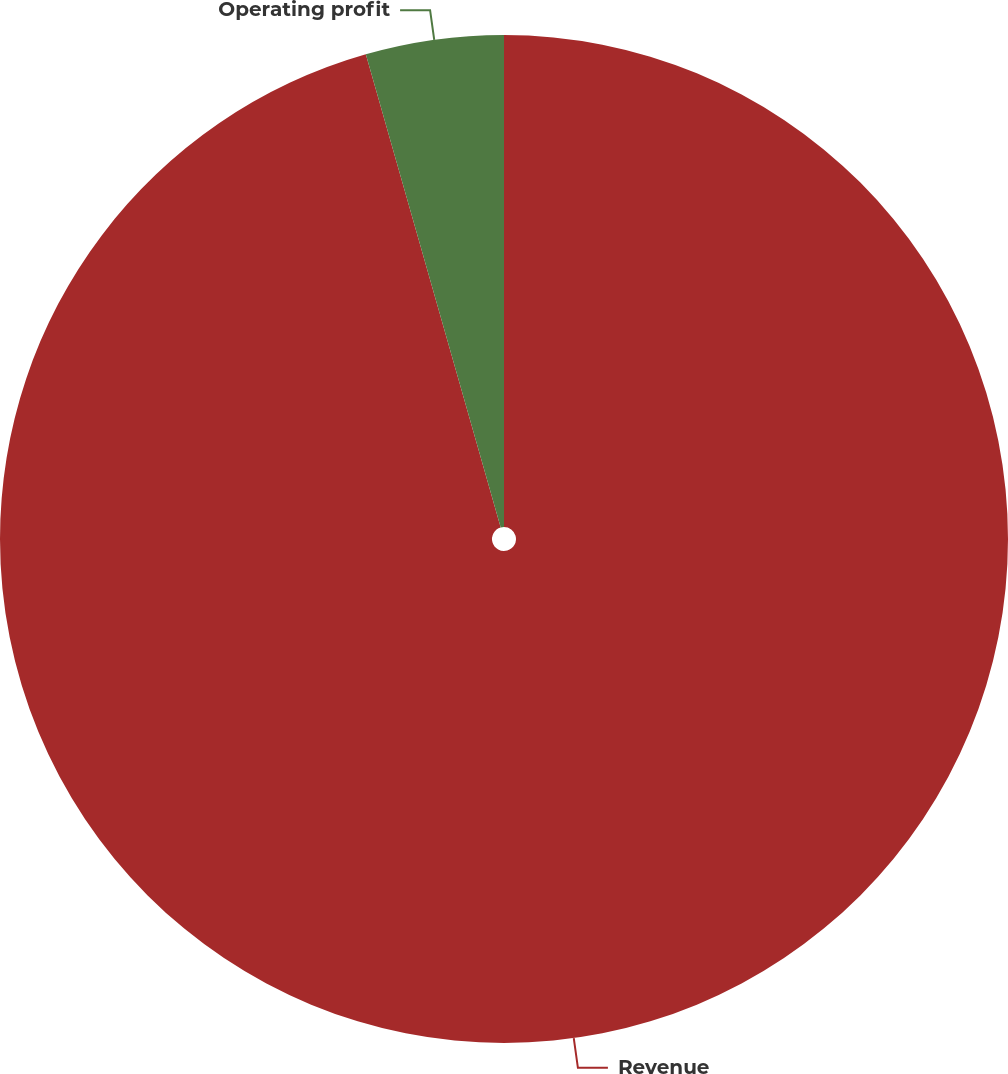Convert chart. <chart><loc_0><loc_0><loc_500><loc_500><pie_chart><fcel>Revenue<fcel>Operating profit<nl><fcel>95.58%<fcel>4.42%<nl></chart> 